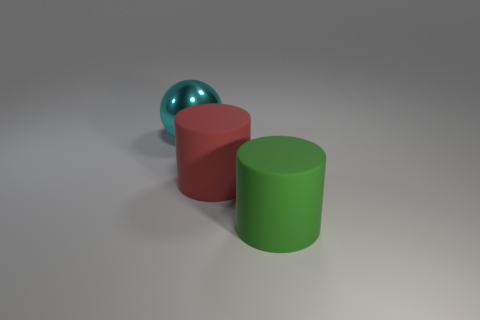Is there another cyan metal thing of the same shape as the metal object?
Keep it short and to the point. No. Is the large metal object the same shape as the red thing?
Your answer should be very brief. No. What number of small objects are either red cylinders or cyan things?
Your response must be concise. 0. Are there more small blue blocks than green objects?
Keep it short and to the point. No. What size is the object that is the same material as the big red cylinder?
Your answer should be compact. Large. Do the rubber cylinder that is behind the green matte thing and the object that is to the left of the red cylinder have the same size?
Your response must be concise. Yes. How many objects are either objects that are to the right of the large metallic ball or cyan rubber blocks?
Offer a very short reply. 2. Is the number of big purple spheres less than the number of metal balls?
Offer a very short reply. Yes. What shape is the big matte object on the left side of the large cylinder that is on the right side of the large matte object behind the big green object?
Your response must be concise. Cylinder. Are any large yellow metallic blocks visible?
Keep it short and to the point. No. 